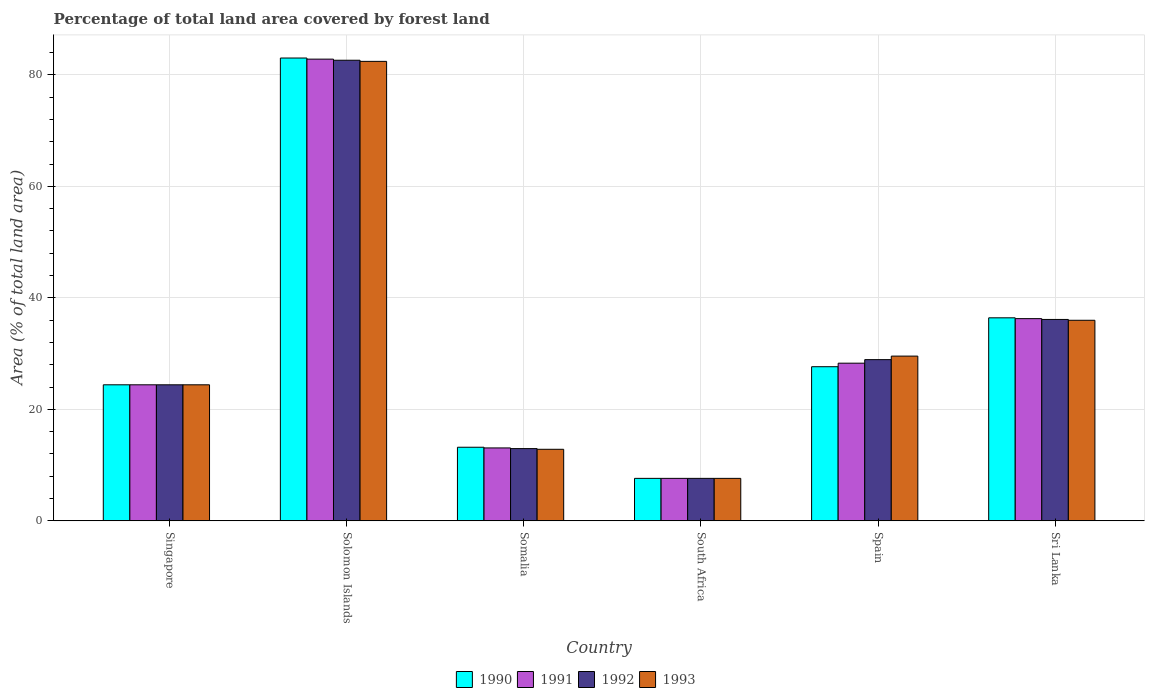How many groups of bars are there?
Your response must be concise. 6. Are the number of bars per tick equal to the number of legend labels?
Provide a short and direct response. Yes. What is the label of the 3rd group of bars from the left?
Your response must be concise. Somalia. What is the percentage of forest land in 1992 in Somalia?
Your answer should be very brief. 12.96. Across all countries, what is the maximum percentage of forest land in 1991?
Offer a very short reply. 82.83. Across all countries, what is the minimum percentage of forest land in 1990?
Make the answer very short. 7.62. In which country was the percentage of forest land in 1993 maximum?
Make the answer very short. Solomon Islands. In which country was the percentage of forest land in 1992 minimum?
Keep it short and to the point. South Africa. What is the total percentage of forest land in 1991 in the graph?
Offer a terse response. 192.49. What is the difference between the percentage of forest land in 1990 in Singapore and that in Sri Lanka?
Keep it short and to the point. -12.02. What is the difference between the percentage of forest land in 1993 in South Africa and the percentage of forest land in 1992 in Spain?
Provide a short and direct response. -21.3. What is the average percentage of forest land in 1992 per country?
Your answer should be very brief. 32.11. In how many countries, is the percentage of forest land in 1993 greater than 36 %?
Offer a terse response. 1. What is the ratio of the percentage of forest land in 1993 in South Africa to that in Spain?
Offer a terse response. 0.26. Is the percentage of forest land in 1993 in Somalia less than that in South Africa?
Your answer should be very brief. No. What is the difference between the highest and the second highest percentage of forest land in 1992?
Keep it short and to the point. 46.5. What is the difference between the highest and the lowest percentage of forest land in 1993?
Offer a terse response. 74.81. In how many countries, is the percentage of forest land in 1992 greater than the average percentage of forest land in 1992 taken over all countries?
Your answer should be very brief. 2. Is the sum of the percentage of forest land in 1991 in Singapore and South Africa greater than the maximum percentage of forest land in 1990 across all countries?
Offer a very short reply. No. What does the 4th bar from the left in Solomon Islands represents?
Offer a very short reply. 1993. What does the 4th bar from the right in Solomon Islands represents?
Your answer should be very brief. 1990. How many bars are there?
Provide a succinct answer. 24. Are the values on the major ticks of Y-axis written in scientific E-notation?
Give a very brief answer. No. Does the graph contain grids?
Keep it short and to the point. Yes. Where does the legend appear in the graph?
Your answer should be very brief. Bottom center. How many legend labels are there?
Make the answer very short. 4. How are the legend labels stacked?
Keep it short and to the point. Horizontal. What is the title of the graph?
Offer a very short reply. Percentage of total land area covered by forest land. What is the label or title of the X-axis?
Make the answer very short. Country. What is the label or title of the Y-axis?
Make the answer very short. Area (% of total land area). What is the Area (% of total land area) of 1990 in Singapore?
Provide a succinct answer. 24.4. What is the Area (% of total land area) of 1991 in Singapore?
Make the answer very short. 24.4. What is the Area (% of total land area) of 1992 in Singapore?
Your answer should be very brief. 24.4. What is the Area (% of total land area) in 1993 in Singapore?
Offer a very short reply. 24.4. What is the Area (% of total land area) in 1990 in Solomon Islands?
Your response must be concise. 83.03. What is the Area (% of total land area) of 1991 in Solomon Islands?
Keep it short and to the point. 82.83. What is the Area (% of total land area) in 1992 in Solomon Islands?
Ensure brevity in your answer.  82.63. What is the Area (% of total land area) of 1993 in Solomon Islands?
Your answer should be very brief. 82.43. What is the Area (% of total land area) of 1990 in Somalia?
Keep it short and to the point. 13.2. What is the Area (% of total land area) of 1991 in Somalia?
Your answer should be very brief. 13.08. What is the Area (% of total land area) of 1992 in Somalia?
Your answer should be compact. 12.96. What is the Area (% of total land area) of 1993 in Somalia?
Keep it short and to the point. 12.83. What is the Area (% of total land area) in 1990 in South Africa?
Provide a succinct answer. 7.62. What is the Area (% of total land area) of 1991 in South Africa?
Offer a terse response. 7.62. What is the Area (% of total land area) in 1992 in South Africa?
Keep it short and to the point. 7.62. What is the Area (% of total land area) of 1993 in South Africa?
Provide a succinct answer. 7.62. What is the Area (% of total land area) in 1990 in Spain?
Your answer should be compact. 27.65. What is the Area (% of total land area) in 1991 in Spain?
Ensure brevity in your answer.  28.28. What is the Area (% of total land area) of 1992 in Spain?
Keep it short and to the point. 28.92. What is the Area (% of total land area) in 1993 in Spain?
Your response must be concise. 29.55. What is the Area (% of total land area) in 1990 in Sri Lanka?
Provide a succinct answer. 36.42. What is the Area (% of total land area) of 1991 in Sri Lanka?
Make the answer very short. 36.27. What is the Area (% of total land area) in 1992 in Sri Lanka?
Offer a very short reply. 36.13. What is the Area (% of total land area) in 1993 in Sri Lanka?
Provide a short and direct response. 35.98. Across all countries, what is the maximum Area (% of total land area) in 1990?
Ensure brevity in your answer.  83.03. Across all countries, what is the maximum Area (% of total land area) of 1991?
Ensure brevity in your answer.  82.83. Across all countries, what is the maximum Area (% of total land area) of 1992?
Offer a terse response. 82.63. Across all countries, what is the maximum Area (% of total land area) of 1993?
Offer a very short reply. 82.43. Across all countries, what is the minimum Area (% of total land area) of 1990?
Give a very brief answer. 7.62. Across all countries, what is the minimum Area (% of total land area) in 1991?
Provide a short and direct response. 7.62. Across all countries, what is the minimum Area (% of total land area) of 1992?
Keep it short and to the point. 7.62. Across all countries, what is the minimum Area (% of total land area) of 1993?
Make the answer very short. 7.62. What is the total Area (% of total land area) in 1990 in the graph?
Provide a short and direct response. 192.32. What is the total Area (% of total land area) in 1991 in the graph?
Offer a terse response. 192.49. What is the total Area (% of total land area) in 1992 in the graph?
Keep it short and to the point. 192.65. What is the total Area (% of total land area) of 1993 in the graph?
Offer a terse response. 192.82. What is the difference between the Area (% of total land area) of 1990 in Singapore and that in Solomon Islands?
Provide a succinct answer. -58.63. What is the difference between the Area (% of total land area) in 1991 in Singapore and that in Solomon Islands?
Offer a very short reply. -58.43. What is the difference between the Area (% of total land area) in 1992 in Singapore and that in Solomon Islands?
Your answer should be compact. -58.23. What is the difference between the Area (% of total land area) of 1993 in Singapore and that in Solomon Islands?
Make the answer very short. -58.03. What is the difference between the Area (% of total land area) of 1990 in Singapore and that in Somalia?
Your answer should be compact. 11.2. What is the difference between the Area (% of total land area) in 1991 in Singapore and that in Somalia?
Offer a terse response. 11.32. What is the difference between the Area (% of total land area) in 1992 in Singapore and that in Somalia?
Ensure brevity in your answer.  11.45. What is the difference between the Area (% of total land area) of 1993 in Singapore and that in Somalia?
Your response must be concise. 11.57. What is the difference between the Area (% of total land area) in 1990 in Singapore and that in South Africa?
Make the answer very short. 16.79. What is the difference between the Area (% of total land area) of 1991 in Singapore and that in South Africa?
Provide a succinct answer. 16.79. What is the difference between the Area (% of total land area) in 1992 in Singapore and that in South Africa?
Ensure brevity in your answer.  16.79. What is the difference between the Area (% of total land area) of 1993 in Singapore and that in South Africa?
Offer a terse response. 16.79. What is the difference between the Area (% of total land area) of 1990 in Singapore and that in Spain?
Keep it short and to the point. -3.25. What is the difference between the Area (% of total land area) in 1991 in Singapore and that in Spain?
Keep it short and to the point. -3.88. What is the difference between the Area (% of total land area) of 1992 in Singapore and that in Spain?
Your answer should be compact. -4.52. What is the difference between the Area (% of total land area) of 1993 in Singapore and that in Spain?
Give a very brief answer. -5.15. What is the difference between the Area (% of total land area) of 1990 in Singapore and that in Sri Lanka?
Make the answer very short. -12.02. What is the difference between the Area (% of total land area) of 1991 in Singapore and that in Sri Lanka?
Provide a succinct answer. -11.87. What is the difference between the Area (% of total land area) in 1992 in Singapore and that in Sri Lanka?
Your answer should be very brief. -11.73. What is the difference between the Area (% of total land area) in 1993 in Singapore and that in Sri Lanka?
Provide a succinct answer. -11.58. What is the difference between the Area (% of total land area) in 1990 in Solomon Islands and that in Somalia?
Provide a succinct answer. 69.83. What is the difference between the Area (% of total land area) of 1991 in Solomon Islands and that in Somalia?
Make the answer very short. 69.75. What is the difference between the Area (% of total land area) of 1992 in Solomon Islands and that in Somalia?
Offer a very short reply. 69.67. What is the difference between the Area (% of total land area) of 1993 in Solomon Islands and that in Somalia?
Your response must be concise. 69.59. What is the difference between the Area (% of total land area) of 1990 in Solomon Islands and that in South Africa?
Offer a very short reply. 75.41. What is the difference between the Area (% of total land area) of 1991 in Solomon Islands and that in South Africa?
Make the answer very short. 75.21. What is the difference between the Area (% of total land area) of 1992 in Solomon Islands and that in South Africa?
Make the answer very short. 75.01. What is the difference between the Area (% of total land area) of 1993 in Solomon Islands and that in South Africa?
Your response must be concise. 74.81. What is the difference between the Area (% of total land area) in 1990 in Solomon Islands and that in Spain?
Your response must be concise. 55.38. What is the difference between the Area (% of total land area) in 1991 in Solomon Islands and that in Spain?
Provide a short and direct response. 54.55. What is the difference between the Area (% of total land area) in 1992 in Solomon Islands and that in Spain?
Offer a very short reply. 53.71. What is the difference between the Area (% of total land area) in 1993 in Solomon Islands and that in Spain?
Provide a short and direct response. 52.88. What is the difference between the Area (% of total land area) in 1990 in Solomon Islands and that in Sri Lanka?
Your response must be concise. 46.61. What is the difference between the Area (% of total land area) in 1991 in Solomon Islands and that in Sri Lanka?
Provide a short and direct response. 46.55. What is the difference between the Area (% of total land area) of 1992 in Solomon Islands and that in Sri Lanka?
Make the answer very short. 46.5. What is the difference between the Area (% of total land area) in 1993 in Solomon Islands and that in Sri Lanka?
Ensure brevity in your answer.  46.45. What is the difference between the Area (% of total land area) of 1990 in Somalia and that in South Africa?
Give a very brief answer. 5.58. What is the difference between the Area (% of total land area) in 1991 in Somalia and that in South Africa?
Offer a terse response. 5.46. What is the difference between the Area (% of total land area) in 1992 in Somalia and that in South Africa?
Offer a terse response. 5.34. What is the difference between the Area (% of total land area) in 1993 in Somalia and that in South Africa?
Keep it short and to the point. 5.22. What is the difference between the Area (% of total land area) in 1990 in Somalia and that in Spain?
Make the answer very short. -14.45. What is the difference between the Area (% of total land area) in 1991 in Somalia and that in Spain?
Your answer should be compact. -15.2. What is the difference between the Area (% of total land area) of 1992 in Somalia and that in Spain?
Keep it short and to the point. -15.96. What is the difference between the Area (% of total land area) of 1993 in Somalia and that in Spain?
Offer a terse response. -16.72. What is the difference between the Area (% of total land area) in 1990 in Somalia and that in Sri Lanka?
Provide a succinct answer. -23.22. What is the difference between the Area (% of total land area) in 1991 in Somalia and that in Sri Lanka?
Offer a terse response. -23.2. What is the difference between the Area (% of total land area) in 1992 in Somalia and that in Sri Lanka?
Provide a succinct answer. -23.17. What is the difference between the Area (% of total land area) in 1993 in Somalia and that in Sri Lanka?
Provide a succinct answer. -23.15. What is the difference between the Area (% of total land area) in 1990 in South Africa and that in Spain?
Give a very brief answer. -20.03. What is the difference between the Area (% of total land area) in 1991 in South Africa and that in Spain?
Make the answer very short. -20.67. What is the difference between the Area (% of total land area) of 1992 in South Africa and that in Spain?
Offer a very short reply. -21.3. What is the difference between the Area (% of total land area) in 1993 in South Africa and that in Spain?
Offer a terse response. -21.93. What is the difference between the Area (% of total land area) in 1990 in South Africa and that in Sri Lanka?
Your answer should be compact. -28.8. What is the difference between the Area (% of total land area) in 1991 in South Africa and that in Sri Lanka?
Provide a succinct answer. -28.66. What is the difference between the Area (% of total land area) of 1992 in South Africa and that in Sri Lanka?
Make the answer very short. -28.51. What is the difference between the Area (% of total land area) in 1993 in South Africa and that in Sri Lanka?
Make the answer very short. -28.36. What is the difference between the Area (% of total land area) in 1990 in Spain and that in Sri Lanka?
Keep it short and to the point. -8.77. What is the difference between the Area (% of total land area) of 1991 in Spain and that in Sri Lanka?
Give a very brief answer. -7.99. What is the difference between the Area (% of total land area) of 1992 in Spain and that in Sri Lanka?
Provide a succinct answer. -7.21. What is the difference between the Area (% of total land area) in 1993 in Spain and that in Sri Lanka?
Offer a very short reply. -6.43. What is the difference between the Area (% of total land area) of 1990 in Singapore and the Area (% of total land area) of 1991 in Solomon Islands?
Make the answer very short. -58.43. What is the difference between the Area (% of total land area) in 1990 in Singapore and the Area (% of total land area) in 1992 in Solomon Islands?
Provide a short and direct response. -58.23. What is the difference between the Area (% of total land area) in 1990 in Singapore and the Area (% of total land area) in 1993 in Solomon Islands?
Make the answer very short. -58.03. What is the difference between the Area (% of total land area) in 1991 in Singapore and the Area (% of total land area) in 1992 in Solomon Islands?
Keep it short and to the point. -58.23. What is the difference between the Area (% of total land area) in 1991 in Singapore and the Area (% of total land area) in 1993 in Solomon Islands?
Your response must be concise. -58.03. What is the difference between the Area (% of total land area) in 1992 in Singapore and the Area (% of total land area) in 1993 in Solomon Islands?
Ensure brevity in your answer.  -58.03. What is the difference between the Area (% of total land area) of 1990 in Singapore and the Area (% of total land area) of 1991 in Somalia?
Ensure brevity in your answer.  11.32. What is the difference between the Area (% of total land area) of 1990 in Singapore and the Area (% of total land area) of 1992 in Somalia?
Provide a short and direct response. 11.45. What is the difference between the Area (% of total land area) in 1990 in Singapore and the Area (% of total land area) in 1993 in Somalia?
Provide a short and direct response. 11.57. What is the difference between the Area (% of total land area) in 1991 in Singapore and the Area (% of total land area) in 1992 in Somalia?
Keep it short and to the point. 11.45. What is the difference between the Area (% of total land area) of 1991 in Singapore and the Area (% of total land area) of 1993 in Somalia?
Offer a very short reply. 11.57. What is the difference between the Area (% of total land area) in 1992 in Singapore and the Area (% of total land area) in 1993 in Somalia?
Offer a terse response. 11.57. What is the difference between the Area (% of total land area) of 1990 in Singapore and the Area (% of total land area) of 1991 in South Africa?
Offer a terse response. 16.79. What is the difference between the Area (% of total land area) in 1990 in Singapore and the Area (% of total land area) in 1992 in South Africa?
Your response must be concise. 16.79. What is the difference between the Area (% of total land area) of 1990 in Singapore and the Area (% of total land area) of 1993 in South Africa?
Your answer should be very brief. 16.79. What is the difference between the Area (% of total land area) in 1991 in Singapore and the Area (% of total land area) in 1992 in South Africa?
Keep it short and to the point. 16.79. What is the difference between the Area (% of total land area) of 1991 in Singapore and the Area (% of total land area) of 1993 in South Africa?
Keep it short and to the point. 16.79. What is the difference between the Area (% of total land area) in 1992 in Singapore and the Area (% of total land area) in 1993 in South Africa?
Make the answer very short. 16.79. What is the difference between the Area (% of total land area) in 1990 in Singapore and the Area (% of total land area) in 1991 in Spain?
Keep it short and to the point. -3.88. What is the difference between the Area (% of total land area) of 1990 in Singapore and the Area (% of total land area) of 1992 in Spain?
Make the answer very short. -4.52. What is the difference between the Area (% of total land area) of 1990 in Singapore and the Area (% of total land area) of 1993 in Spain?
Offer a very short reply. -5.15. What is the difference between the Area (% of total land area) in 1991 in Singapore and the Area (% of total land area) in 1992 in Spain?
Your answer should be very brief. -4.52. What is the difference between the Area (% of total land area) in 1991 in Singapore and the Area (% of total land area) in 1993 in Spain?
Provide a short and direct response. -5.15. What is the difference between the Area (% of total land area) of 1992 in Singapore and the Area (% of total land area) of 1993 in Spain?
Your answer should be compact. -5.15. What is the difference between the Area (% of total land area) in 1990 in Singapore and the Area (% of total land area) in 1991 in Sri Lanka?
Your response must be concise. -11.87. What is the difference between the Area (% of total land area) in 1990 in Singapore and the Area (% of total land area) in 1992 in Sri Lanka?
Keep it short and to the point. -11.73. What is the difference between the Area (% of total land area) of 1990 in Singapore and the Area (% of total land area) of 1993 in Sri Lanka?
Your answer should be very brief. -11.58. What is the difference between the Area (% of total land area) in 1991 in Singapore and the Area (% of total land area) in 1992 in Sri Lanka?
Make the answer very short. -11.73. What is the difference between the Area (% of total land area) in 1991 in Singapore and the Area (% of total land area) in 1993 in Sri Lanka?
Provide a short and direct response. -11.58. What is the difference between the Area (% of total land area) in 1992 in Singapore and the Area (% of total land area) in 1993 in Sri Lanka?
Your answer should be compact. -11.58. What is the difference between the Area (% of total land area) in 1990 in Solomon Islands and the Area (% of total land area) in 1991 in Somalia?
Keep it short and to the point. 69.95. What is the difference between the Area (% of total land area) in 1990 in Solomon Islands and the Area (% of total land area) in 1992 in Somalia?
Your response must be concise. 70.07. What is the difference between the Area (% of total land area) of 1990 in Solomon Islands and the Area (% of total land area) of 1993 in Somalia?
Offer a terse response. 70.19. What is the difference between the Area (% of total land area) of 1991 in Solomon Islands and the Area (% of total land area) of 1992 in Somalia?
Your answer should be compact. 69.87. What is the difference between the Area (% of total land area) in 1991 in Solomon Islands and the Area (% of total land area) in 1993 in Somalia?
Ensure brevity in your answer.  69.99. What is the difference between the Area (% of total land area) of 1992 in Solomon Islands and the Area (% of total land area) of 1993 in Somalia?
Give a very brief answer. 69.79. What is the difference between the Area (% of total land area) in 1990 in Solomon Islands and the Area (% of total land area) in 1991 in South Africa?
Offer a very short reply. 75.41. What is the difference between the Area (% of total land area) in 1990 in Solomon Islands and the Area (% of total land area) in 1992 in South Africa?
Ensure brevity in your answer.  75.41. What is the difference between the Area (% of total land area) of 1990 in Solomon Islands and the Area (% of total land area) of 1993 in South Africa?
Your answer should be compact. 75.41. What is the difference between the Area (% of total land area) of 1991 in Solomon Islands and the Area (% of total land area) of 1992 in South Africa?
Make the answer very short. 75.21. What is the difference between the Area (% of total land area) in 1991 in Solomon Islands and the Area (% of total land area) in 1993 in South Africa?
Give a very brief answer. 75.21. What is the difference between the Area (% of total land area) of 1992 in Solomon Islands and the Area (% of total land area) of 1993 in South Africa?
Your answer should be very brief. 75.01. What is the difference between the Area (% of total land area) in 1990 in Solomon Islands and the Area (% of total land area) in 1991 in Spain?
Offer a very short reply. 54.75. What is the difference between the Area (% of total land area) in 1990 in Solomon Islands and the Area (% of total land area) in 1992 in Spain?
Give a very brief answer. 54.11. What is the difference between the Area (% of total land area) in 1990 in Solomon Islands and the Area (% of total land area) in 1993 in Spain?
Your response must be concise. 53.48. What is the difference between the Area (% of total land area) in 1991 in Solomon Islands and the Area (% of total land area) in 1992 in Spain?
Your answer should be compact. 53.91. What is the difference between the Area (% of total land area) in 1991 in Solomon Islands and the Area (% of total land area) in 1993 in Spain?
Provide a short and direct response. 53.28. What is the difference between the Area (% of total land area) of 1992 in Solomon Islands and the Area (% of total land area) of 1993 in Spain?
Keep it short and to the point. 53.08. What is the difference between the Area (% of total land area) in 1990 in Solomon Islands and the Area (% of total land area) in 1991 in Sri Lanka?
Your response must be concise. 46.75. What is the difference between the Area (% of total land area) of 1990 in Solomon Islands and the Area (% of total land area) of 1992 in Sri Lanka?
Offer a very short reply. 46.9. What is the difference between the Area (% of total land area) in 1990 in Solomon Islands and the Area (% of total land area) in 1993 in Sri Lanka?
Offer a very short reply. 47.05. What is the difference between the Area (% of total land area) of 1991 in Solomon Islands and the Area (% of total land area) of 1992 in Sri Lanka?
Your answer should be very brief. 46.7. What is the difference between the Area (% of total land area) in 1991 in Solomon Islands and the Area (% of total land area) in 1993 in Sri Lanka?
Give a very brief answer. 46.85. What is the difference between the Area (% of total land area) in 1992 in Solomon Islands and the Area (% of total land area) in 1993 in Sri Lanka?
Offer a very short reply. 46.65. What is the difference between the Area (% of total land area) of 1990 in Somalia and the Area (% of total land area) of 1991 in South Africa?
Ensure brevity in your answer.  5.58. What is the difference between the Area (% of total land area) in 1990 in Somalia and the Area (% of total land area) in 1992 in South Africa?
Your response must be concise. 5.58. What is the difference between the Area (% of total land area) in 1990 in Somalia and the Area (% of total land area) in 1993 in South Africa?
Offer a very short reply. 5.58. What is the difference between the Area (% of total land area) of 1991 in Somalia and the Area (% of total land area) of 1992 in South Africa?
Keep it short and to the point. 5.46. What is the difference between the Area (% of total land area) in 1991 in Somalia and the Area (% of total land area) in 1993 in South Africa?
Provide a succinct answer. 5.46. What is the difference between the Area (% of total land area) in 1992 in Somalia and the Area (% of total land area) in 1993 in South Africa?
Make the answer very short. 5.34. What is the difference between the Area (% of total land area) of 1990 in Somalia and the Area (% of total land area) of 1991 in Spain?
Your answer should be very brief. -15.08. What is the difference between the Area (% of total land area) of 1990 in Somalia and the Area (% of total land area) of 1992 in Spain?
Give a very brief answer. -15.72. What is the difference between the Area (% of total land area) of 1990 in Somalia and the Area (% of total land area) of 1993 in Spain?
Give a very brief answer. -16.35. What is the difference between the Area (% of total land area) in 1991 in Somalia and the Area (% of total land area) in 1992 in Spain?
Offer a very short reply. -15.84. What is the difference between the Area (% of total land area) of 1991 in Somalia and the Area (% of total land area) of 1993 in Spain?
Your answer should be very brief. -16.47. What is the difference between the Area (% of total land area) of 1992 in Somalia and the Area (% of total land area) of 1993 in Spain?
Ensure brevity in your answer.  -16.6. What is the difference between the Area (% of total land area) in 1990 in Somalia and the Area (% of total land area) in 1991 in Sri Lanka?
Give a very brief answer. -23.07. What is the difference between the Area (% of total land area) of 1990 in Somalia and the Area (% of total land area) of 1992 in Sri Lanka?
Ensure brevity in your answer.  -22.93. What is the difference between the Area (% of total land area) of 1990 in Somalia and the Area (% of total land area) of 1993 in Sri Lanka?
Offer a very short reply. -22.78. What is the difference between the Area (% of total land area) in 1991 in Somalia and the Area (% of total land area) in 1992 in Sri Lanka?
Your answer should be compact. -23.05. What is the difference between the Area (% of total land area) of 1991 in Somalia and the Area (% of total land area) of 1993 in Sri Lanka?
Your response must be concise. -22.9. What is the difference between the Area (% of total land area) in 1992 in Somalia and the Area (% of total land area) in 1993 in Sri Lanka?
Make the answer very short. -23.02. What is the difference between the Area (% of total land area) of 1990 in South Africa and the Area (% of total land area) of 1991 in Spain?
Make the answer very short. -20.67. What is the difference between the Area (% of total land area) in 1990 in South Africa and the Area (% of total land area) in 1992 in Spain?
Ensure brevity in your answer.  -21.3. What is the difference between the Area (% of total land area) of 1990 in South Africa and the Area (% of total land area) of 1993 in Spain?
Offer a terse response. -21.93. What is the difference between the Area (% of total land area) in 1991 in South Africa and the Area (% of total land area) in 1992 in Spain?
Your answer should be compact. -21.3. What is the difference between the Area (% of total land area) in 1991 in South Africa and the Area (% of total land area) in 1993 in Spain?
Give a very brief answer. -21.93. What is the difference between the Area (% of total land area) in 1992 in South Africa and the Area (% of total land area) in 1993 in Spain?
Make the answer very short. -21.93. What is the difference between the Area (% of total land area) in 1990 in South Africa and the Area (% of total land area) in 1991 in Sri Lanka?
Your answer should be compact. -28.66. What is the difference between the Area (% of total land area) of 1990 in South Africa and the Area (% of total land area) of 1992 in Sri Lanka?
Offer a very short reply. -28.51. What is the difference between the Area (% of total land area) of 1990 in South Africa and the Area (% of total land area) of 1993 in Sri Lanka?
Give a very brief answer. -28.36. What is the difference between the Area (% of total land area) of 1991 in South Africa and the Area (% of total land area) of 1992 in Sri Lanka?
Ensure brevity in your answer.  -28.51. What is the difference between the Area (% of total land area) of 1991 in South Africa and the Area (% of total land area) of 1993 in Sri Lanka?
Make the answer very short. -28.36. What is the difference between the Area (% of total land area) in 1992 in South Africa and the Area (% of total land area) in 1993 in Sri Lanka?
Offer a very short reply. -28.36. What is the difference between the Area (% of total land area) in 1990 in Spain and the Area (% of total land area) in 1991 in Sri Lanka?
Your response must be concise. -8.62. What is the difference between the Area (% of total land area) of 1990 in Spain and the Area (% of total land area) of 1992 in Sri Lanka?
Provide a succinct answer. -8.48. What is the difference between the Area (% of total land area) of 1990 in Spain and the Area (% of total land area) of 1993 in Sri Lanka?
Keep it short and to the point. -8.33. What is the difference between the Area (% of total land area) of 1991 in Spain and the Area (% of total land area) of 1992 in Sri Lanka?
Give a very brief answer. -7.84. What is the difference between the Area (% of total land area) of 1991 in Spain and the Area (% of total land area) of 1993 in Sri Lanka?
Give a very brief answer. -7.7. What is the difference between the Area (% of total land area) in 1992 in Spain and the Area (% of total land area) in 1993 in Sri Lanka?
Provide a short and direct response. -7.06. What is the average Area (% of total land area) of 1990 per country?
Provide a short and direct response. 32.05. What is the average Area (% of total land area) in 1991 per country?
Your response must be concise. 32.08. What is the average Area (% of total land area) in 1992 per country?
Make the answer very short. 32.11. What is the average Area (% of total land area) in 1993 per country?
Your response must be concise. 32.14. What is the difference between the Area (% of total land area) of 1990 and Area (% of total land area) of 1992 in Singapore?
Offer a very short reply. 0. What is the difference between the Area (% of total land area) in 1991 and Area (% of total land area) in 1992 in Singapore?
Your answer should be compact. 0. What is the difference between the Area (% of total land area) in 1991 and Area (% of total land area) in 1993 in Singapore?
Provide a short and direct response. 0. What is the difference between the Area (% of total land area) of 1990 and Area (% of total land area) of 1991 in Solomon Islands?
Your answer should be compact. 0.2. What is the difference between the Area (% of total land area) in 1990 and Area (% of total land area) in 1992 in Solomon Islands?
Your answer should be compact. 0.4. What is the difference between the Area (% of total land area) in 1990 and Area (% of total land area) in 1993 in Solomon Islands?
Your answer should be very brief. 0.6. What is the difference between the Area (% of total land area) of 1991 and Area (% of total land area) of 1992 in Solomon Islands?
Give a very brief answer. 0.2. What is the difference between the Area (% of total land area) in 1991 and Area (% of total land area) in 1993 in Solomon Islands?
Provide a succinct answer. 0.4. What is the difference between the Area (% of total land area) of 1992 and Area (% of total land area) of 1993 in Solomon Islands?
Your answer should be compact. 0.2. What is the difference between the Area (% of total land area) in 1990 and Area (% of total land area) in 1991 in Somalia?
Your response must be concise. 0.12. What is the difference between the Area (% of total land area) in 1990 and Area (% of total land area) in 1992 in Somalia?
Ensure brevity in your answer.  0.24. What is the difference between the Area (% of total land area) in 1990 and Area (% of total land area) in 1993 in Somalia?
Your answer should be compact. 0.37. What is the difference between the Area (% of total land area) in 1991 and Area (% of total land area) in 1992 in Somalia?
Your answer should be compact. 0.12. What is the difference between the Area (% of total land area) of 1991 and Area (% of total land area) of 1993 in Somalia?
Keep it short and to the point. 0.24. What is the difference between the Area (% of total land area) of 1992 and Area (% of total land area) of 1993 in Somalia?
Your response must be concise. 0.12. What is the difference between the Area (% of total land area) in 1990 and Area (% of total land area) in 1991 in South Africa?
Your answer should be compact. 0. What is the difference between the Area (% of total land area) of 1990 and Area (% of total land area) of 1993 in South Africa?
Your response must be concise. 0. What is the difference between the Area (% of total land area) of 1991 and Area (% of total land area) of 1993 in South Africa?
Your answer should be compact. 0. What is the difference between the Area (% of total land area) in 1992 and Area (% of total land area) in 1993 in South Africa?
Offer a terse response. 0. What is the difference between the Area (% of total land area) in 1990 and Area (% of total land area) in 1991 in Spain?
Provide a short and direct response. -0.63. What is the difference between the Area (% of total land area) of 1990 and Area (% of total land area) of 1992 in Spain?
Ensure brevity in your answer.  -1.27. What is the difference between the Area (% of total land area) of 1990 and Area (% of total land area) of 1993 in Spain?
Ensure brevity in your answer.  -1.9. What is the difference between the Area (% of total land area) in 1991 and Area (% of total land area) in 1992 in Spain?
Your response must be concise. -0.63. What is the difference between the Area (% of total land area) of 1991 and Area (% of total land area) of 1993 in Spain?
Keep it short and to the point. -1.27. What is the difference between the Area (% of total land area) of 1992 and Area (% of total land area) of 1993 in Spain?
Keep it short and to the point. -0.63. What is the difference between the Area (% of total land area) of 1990 and Area (% of total land area) of 1991 in Sri Lanka?
Keep it short and to the point. 0.15. What is the difference between the Area (% of total land area) in 1990 and Area (% of total land area) in 1992 in Sri Lanka?
Keep it short and to the point. 0.29. What is the difference between the Area (% of total land area) in 1990 and Area (% of total land area) in 1993 in Sri Lanka?
Your response must be concise. 0.44. What is the difference between the Area (% of total land area) of 1991 and Area (% of total land area) of 1992 in Sri Lanka?
Your answer should be compact. 0.15. What is the difference between the Area (% of total land area) in 1991 and Area (% of total land area) in 1993 in Sri Lanka?
Your answer should be very brief. 0.29. What is the difference between the Area (% of total land area) of 1992 and Area (% of total land area) of 1993 in Sri Lanka?
Ensure brevity in your answer.  0.15. What is the ratio of the Area (% of total land area) in 1990 in Singapore to that in Solomon Islands?
Ensure brevity in your answer.  0.29. What is the ratio of the Area (% of total land area) in 1991 in Singapore to that in Solomon Islands?
Give a very brief answer. 0.29. What is the ratio of the Area (% of total land area) in 1992 in Singapore to that in Solomon Islands?
Ensure brevity in your answer.  0.3. What is the ratio of the Area (% of total land area) in 1993 in Singapore to that in Solomon Islands?
Give a very brief answer. 0.3. What is the ratio of the Area (% of total land area) in 1990 in Singapore to that in Somalia?
Provide a short and direct response. 1.85. What is the ratio of the Area (% of total land area) of 1991 in Singapore to that in Somalia?
Give a very brief answer. 1.87. What is the ratio of the Area (% of total land area) of 1992 in Singapore to that in Somalia?
Ensure brevity in your answer.  1.88. What is the ratio of the Area (% of total land area) in 1993 in Singapore to that in Somalia?
Your response must be concise. 1.9. What is the ratio of the Area (% of total land area) in 1990 in Singapore to that in South Africa?
Provide a succinct answer. 3.2. What is the ratio of the Area (% of total land area) of 1991 in Singapore to that in South Africa?
Keep it short and to the point. 3.2. What is the ratio of the Area (% of total land area) in 1992 in Singapore to that in South Africa?
Keep it short and to the point. 3.2. What is the ratio of the Area (% of total land area) of 1993 in Singapore to that in South Africa?
Offer a very short reply. 3.2. What is the ratio of the Area (% of total land area) in 1990 in Singapore to that in Spain?
Ensure brevity in your answer.  0.88. What is the ratio of the Area (% of total land area) of 1991 in Singapore to that in Spain?
Keep it short and to the point. 0.86. What is the ratio of the Area (% of total land area) of 1992 in Singapore to that in Spain?
Offer a very short reply. 0.84. What is the ratio of the Area (% of total land area) of 1993 in Singapore to that in Spain?
Give a very brief answer. 0.83. What is the ratio of the Area (% of total land area) in 1990 in Singapore to that in Sri Lanka?
Give a very brief answer. 0.67. What is the ratio of the Area (% of total land area) in 1991 in Singapore to that in Sri Lanka?
Your answer should be compact. 0.67. What is the ratio of the Area (% of total land area) in 1992 in Singapore to that in Sri Lanka?
Ensure brevity in your answer.  0.68. What is the ratio of the Area (% of total land area) of 1993 in Singapore to that in Sri Lanka?
Provide a succinct answer. 0.68. What is the ratio of the Area (% of total land area) of 1990 in Solomon Islands to that in Somalia?
Provide a short and direct response. 6.29. What is the ratio of the Area (% of total land area) of 1991 in Solomon Islands to that in Somalia?
Give a very brief answer. 6.33. What is the ratio of the Area (% of total land area) in 1992 in Solomon Islands to that in Somalia?
Make the answer very short. 6.38. What is the ratio of the Area (% of total land area) in 1993 in Solomon Islands to that in Somalia?
Keep it short and to the point. 6.42. What is the ratio of the Area (% of total land area) of 1990 in Solomon Islands to that in South Africa?
Offer a very short reply. 10.9. What is the ratio of the Area (% of total land area) in 1991 in Solomon Islands to that in South Africa?
Give a very brief answer. 10.87. What is the ratio of the Area (% of total land area) in 1992 in Solomon Islands to that in South Africa?
Give a very brief answer. 10.85. What is the ratio of the Area (% of total land area) of 1993 in Solomon Islands to that in South Africa?
Make the answer very short. 10.82. What is the ratio of the Area (% of total land area) of 1990 in Solomon Islands to that in Spain?
Your answer should be very brief. 3. What is the ratio of the Area (% of total land area) of 1991 in Solomon Islands to that in Spain?
Keep it short and to the point. 2.93. What is the ratio of the Area (% of total land area) of 1992 in Solomon Islands to that in Spain?
Your answer should be very brief. 2.86. What is the ratio of the Area (% of total land area) in 1993 in Solomon Islands to that in Spain?
Your answer should be compact. 2.79. What is the ratio of the Area (% of total land area) of 1990 in Solomon Islands to that in Sri Lanka?
Ensure brevity in your answer.  2.28. What is the ratio of the Area (% of total land area) of 1991 in Solomon Islands to that in Sri Lanka?
Ensure brevity in your answer.  2.28. What is the ratio of the Area (% of total land area) in 1992 in Solomon Islands to that in Sri Lanka?
Your answer should be very brief. 2.29. What is the ratio of the Area (% of total land area) in 1993 in Solomon Islands to that in Sri Lanka?
Give a very brief answer. 2.29. What is the ratio of the Area (% of total land area) in 1990 in Somalia to that in South Africa?
Provide a succinct answer. 1.73. What is the ratio of the Area (% of total land area) of 1991 in Somalia to that in South Africa?
Keep it short and to the point. 1.72. What is the ratio of the Area (% of total land area) in 1992 in Somalia to that in South Africa?
Your answer should be compact. 1.7. What is the ratio of the Area (% of total land area) of 1993 in Somalia to that in South Africa?
Make the answer very short. 1.68. What is the ratio of the Area (% of total land area) in 1990 in Somalia to that in Spain?
Your answer should be very brief. 0.48. What is the ratio of the Area (% of total land area) of 1991 in Somalia to that in Spain?
Offer a very short reply. 0.46. What is the ratio of the Area (% of total land area) of 1992 in Somalia to that in Spain?
Provide a succinct answer. 0.45. What is the ratio of the Area (% of total land area) of 1993 in Somalia to that in Spain?
Offer a very short reply. 0.43. What is the ratio of the Area (% of total land area) in 1990 in Somalia to that in Sri Lanka?
Ensure brevity in your answer.  0.36. What is the ratio of the Area (% of total land area) in 1991 in Somalia to that in Sri Lanka?
Ensure brevity in your answer.  0.36. What is the ratio of the Area (% of total land area) of 1992 in Somalia to that in Sri Lanka?
Your response must be concise. 0.36. What is the ratio of the Area (% of total land area) in 1993 in Somalia to that in Sri Lanka?
Make the answer very short. 0.36. What is the ratio of the Area (% of total land area) in 1990 in South Africa to that in Spain?
Make the answer very short. 0.28. What is the ratio of the Area (% of total land area) in 1991 in South Africa to that in Spain?
Your response must be concise. 0.27. What is the ratio of the Area (% of total land area) of 1992 in South Africa to that in Spain?
Give a very brief answer. 0.26. What is the ratio of the Area (% of total land area) in 1993 in South Africa to that in Spain?
Keep it short and to the point. 0.26. What is the ratio of the Area (% of total land area) in 1990 in South Africa to that in Sri Lanka?
Provide a succinct answer. 0.21. What is the ratio of the Area (% of total land area) in 1991 in South Africa to that in Sri Lanka?
Keep it short and to the point. 0.21. What is the ratio of the Area (% of total land area) of 1992 in South Africa to that in Sri Lanka?
Keep it short and to the point. 0.21. What is the ratio of the Area (% of total land area) of 1993 in South Africa to that in Sri Lanka?
Ensure brevity in your answer.  0.21. What is the ratio of the Area (% of total land area) in 1990 in Spain to that in Sri Lanka?
Keep it short and to the point. 0.76. What is the ratio of the Area (% of total land area) in 1991 in Spain to that in Sri Lanka?
Your response must be concise. 0.78. What is the ratio of the Area (% of total land area) of 1992 in Spain to that in Sri Lanka?
Give a very brief answer. 0.8. What is the ratio of the Area (% of total land area) of 1993 in Spain to that in Sri Lanka?
Offer a terse response. 0.82. What is the difference between the highest and the second highest Area (% of total land area) of 1990?
Keep it short and to the point. 46.61. What is the difference between the highest and the second highest Area (% of total land area) in 1991?
Your answer should be very brief. 46.55. What is the difference between the highest and the second highest Area (% of total land area) of 1992?
Your answer should be compact. 46.5. What is the difference between the highest and the second highest Area (% of total land area) in 1993?
Provide a succinct answer. 46.45. What is the difference between the highest and the lowest Area (% of total land area) of 1990?
Your answer should be compact. 75.41. What is the difference between the highest and the lowest Area (% of total land area) in 1991?
Provide a short and direct response. 75.21. What is the difference between the highest and the lowest Area (% of total land area) in 1992?
Your answer should be compact. 75.01. What is the difference between the highest and the lowest Area (% of total land area) of 1993?
Give a very brief answer. 74.81. 